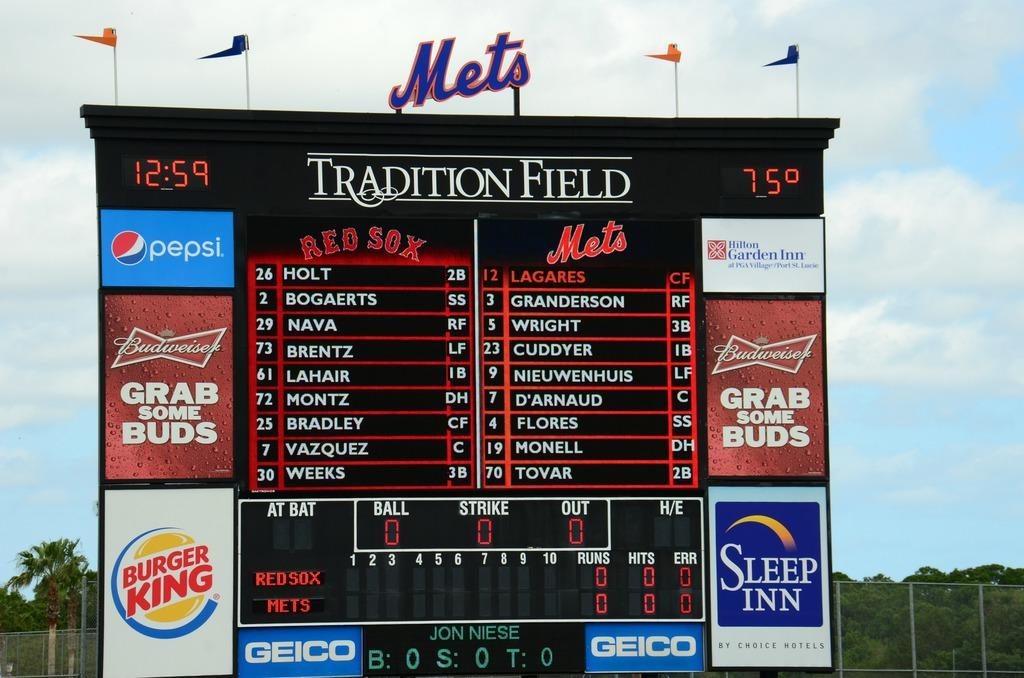Provide a one-sentence caption for the provided image. A scoreboard for the Red Sox playing the Mets at Tradition Field. 